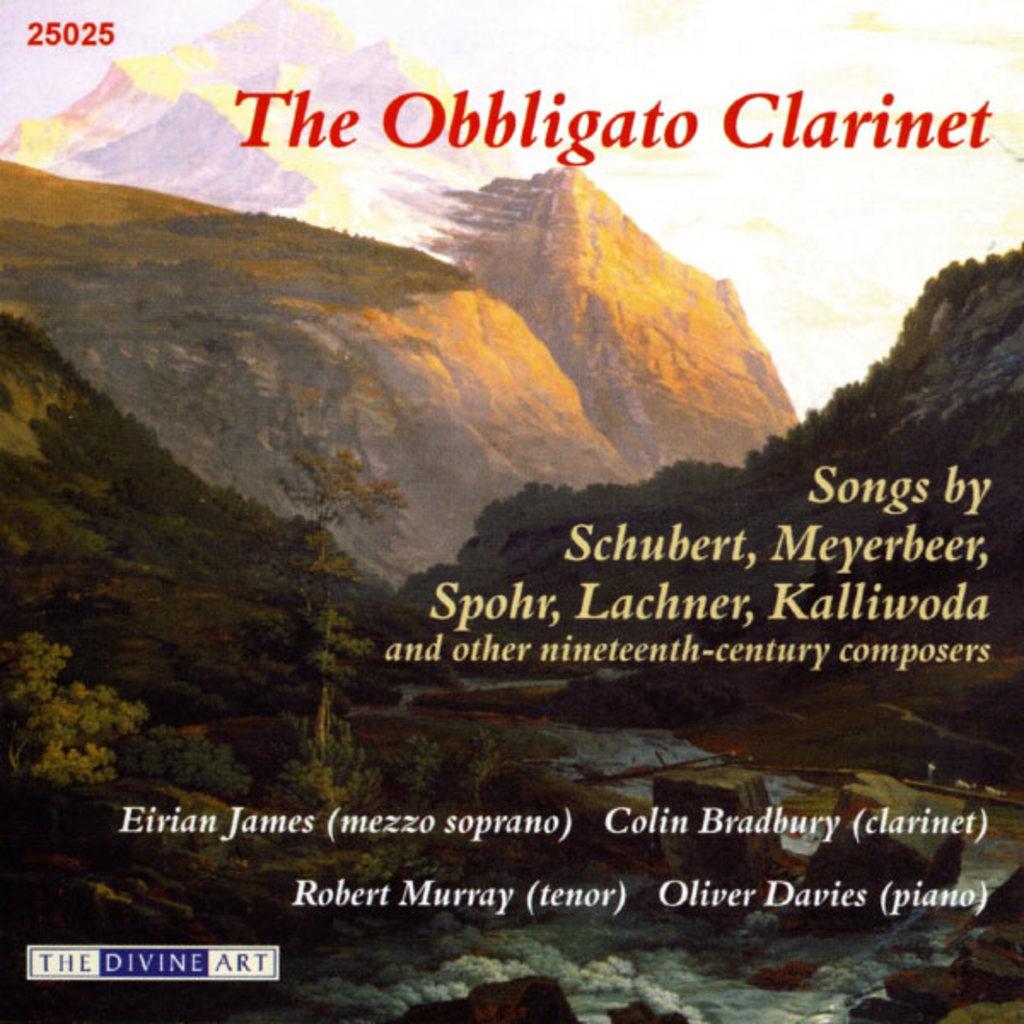Who played piano?
Give a very brief answer. Oliver davies. What is the number in the top left corner?
Your response must be concise. 25025. 